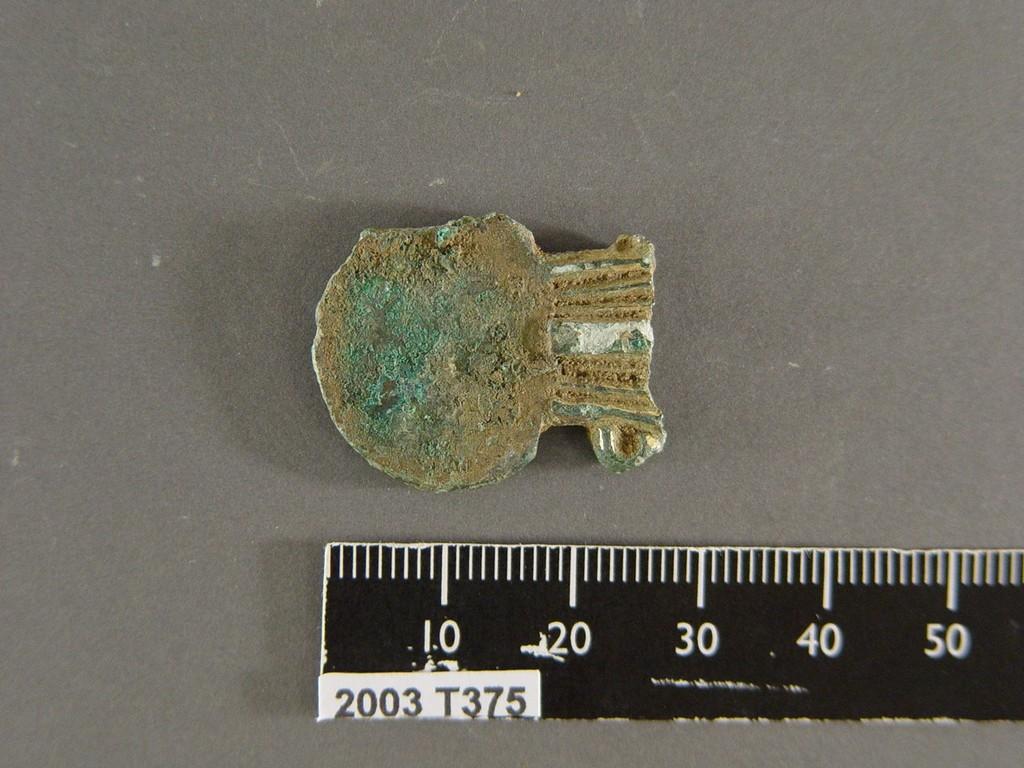What is the length of the object?
Your answer should be compact. 27. What is the year on the ruler?
Offer a very short reply. 2003. 